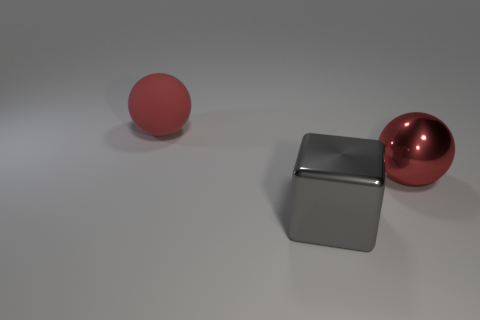Is there anything else that has the same shape as the big gray metallic thing?
Ensure brevity in your answer.  No. What number of things are either things in front of the big red metal ball or big gray metal blocks on the right side of the red rubber ball?
Your answer should be compact. 1. How many shiny cubes have the same color as the shiny sphere?
Ensure brevity in your answer.  0. The other thing that is the same shape as the large red matte thing is what color?
Provide a short and direct response. Red. What shape is the large thing that is both behind the gray shiny block and on the left side of the shiny sphere?
Your answer should be compact. Sphere. Is the number of large cubes greater than the number of tiny cyan matte balls?
Provide a short and direct response. Yes. There is a red matte thing that is left of the large gray thing; is there a matte thing in front of it?
Offer a terse response. No. Is the color of the metal block the same as the large metal ball?
Give a very brief answer. No. How many other things are the same shape as the red matte thing?
Give a very brief answer. 1. Are there more spheres to the right of the block than gray blocks that are behind the red metal object?
Offer a very short reply. Yes. 